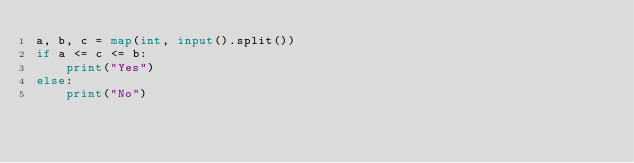Convert code to text. <code><loc_0><loc_0><loc_500><loc_500><_Python_>a, b, c = map(int, input().split())
if a <= c <= b:
    print("Yes")
else:
    print("No")</code> 